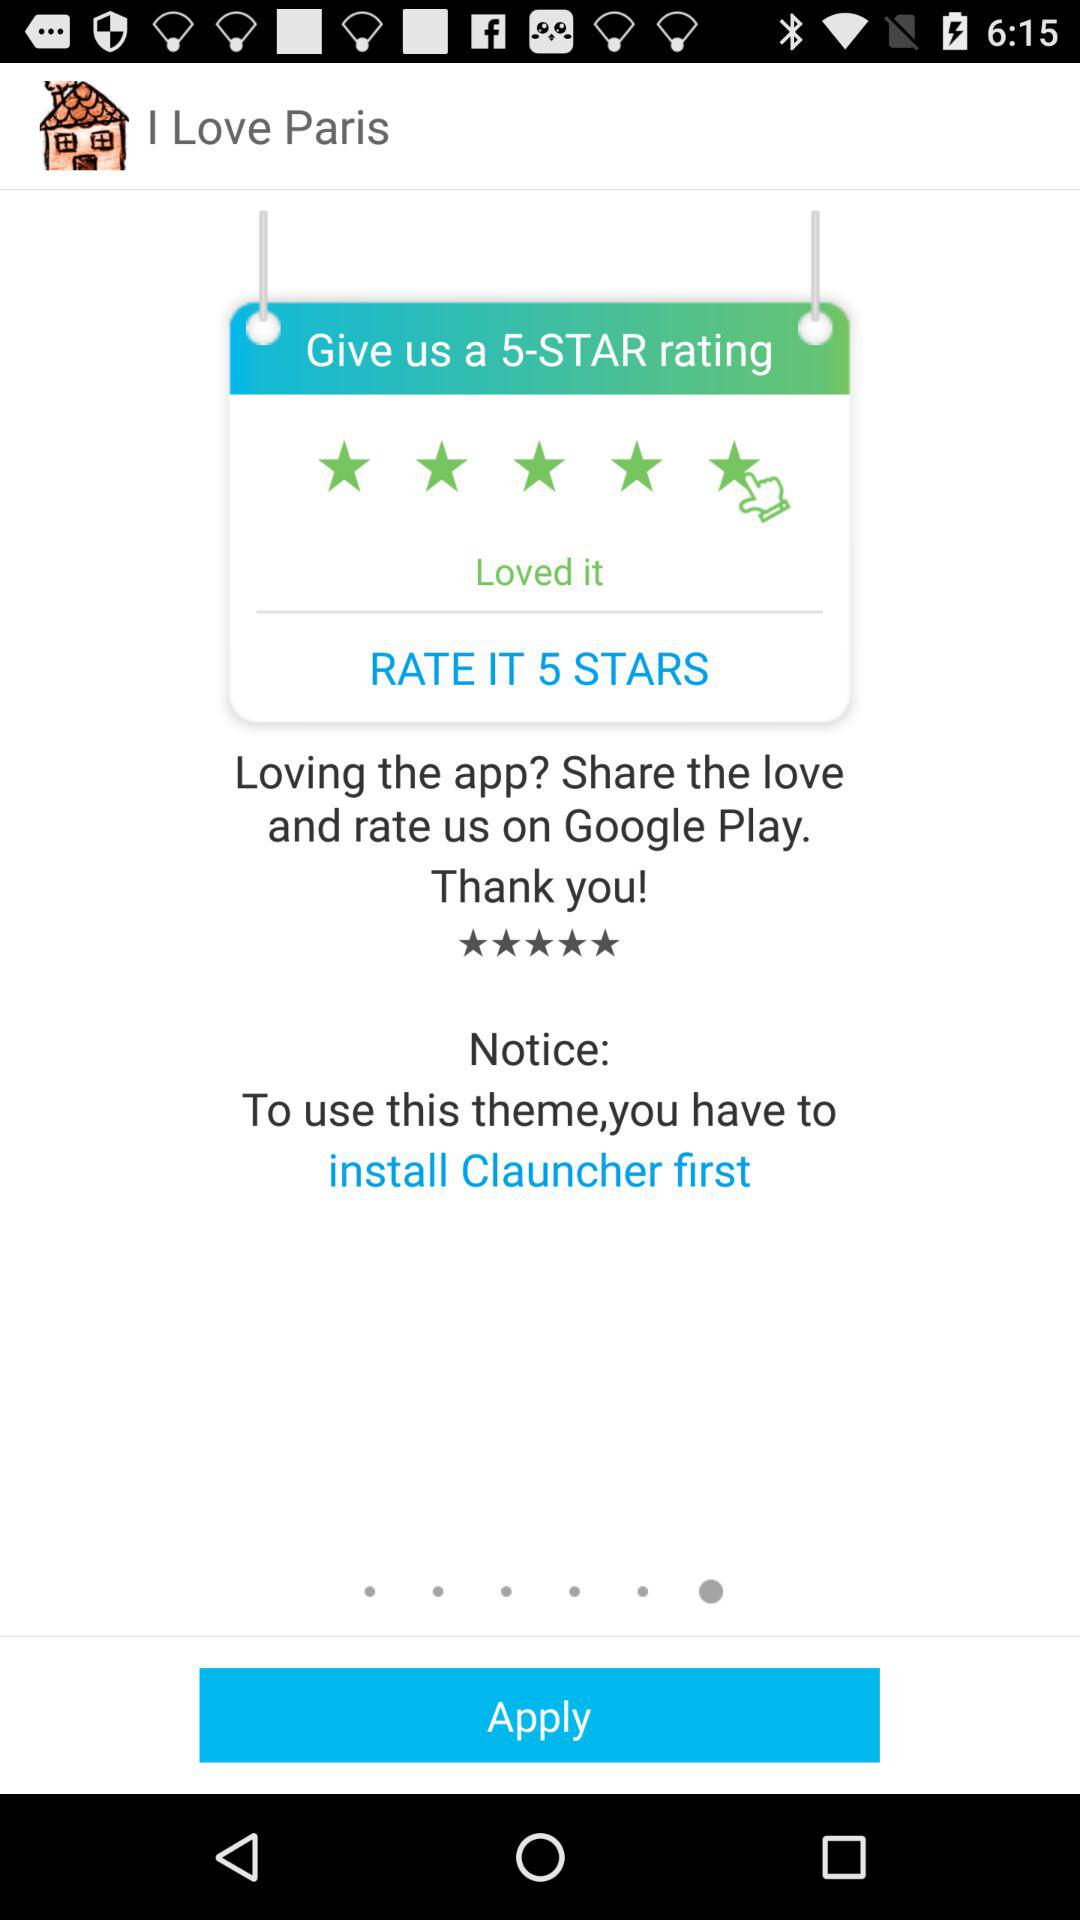What is the app name? The app name is "I Love Paris". 